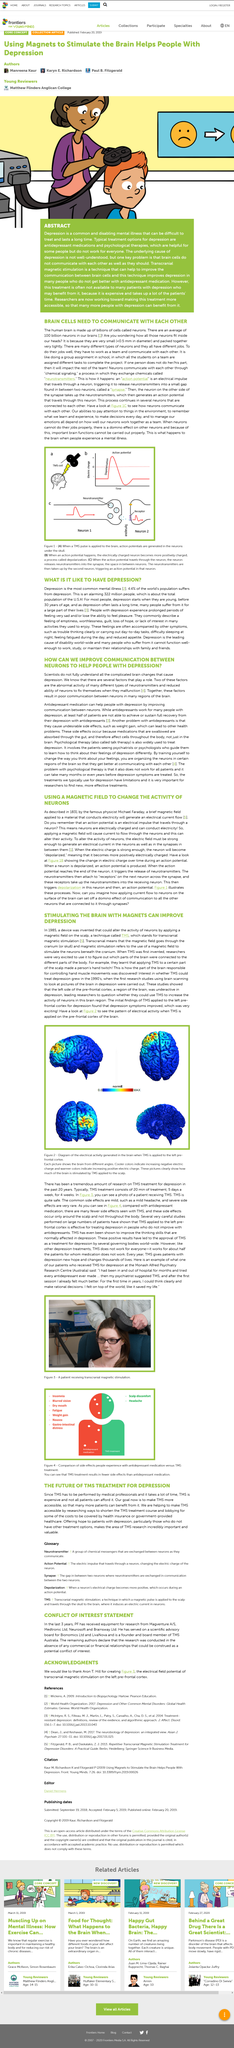Point out several critical features in this image. The above picture depicts a patient receiving transcranial magnetic stimulation. The article asserts that the use of a particular type of medication can aid in improving communication between neurons and thus provide relief to individuals suffering from depression. When a TMS pulse is applied to the brain, action potentials are generated in the neurons under the skull. The left pre-frontal cortex is the part of the brain that is yellow and red in Figure 2. Transcranial magnetic stimulation (TMS) to the left pre-frontal cortex is effective in treating depression. 